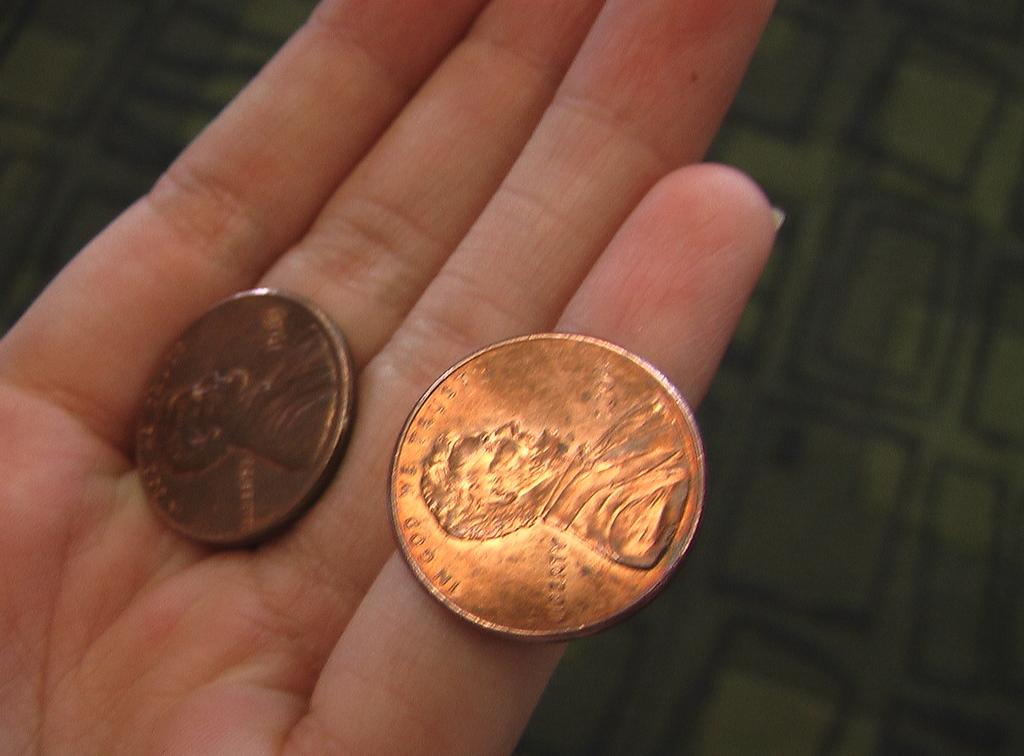What objects are present in the image? There are two coins in the image. Where are the coins located? The coins are on a person's hand. What can be seen in the background of the image? There is a green color cloth in the background of the image. What type of paper can be seen in the image? There is no paper present in the image; it only features two coins on a person's hand and a green color cloth in the background. 